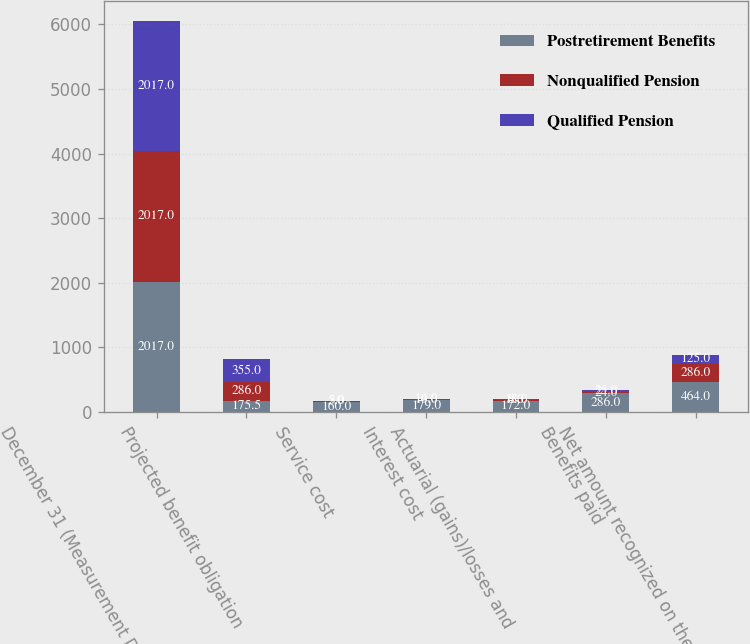Convert chart to OTSL. <chart><loc_0><loc_0><loc_500><loc_500><stacked_bar_chart><ecel><fcel>December 31 (Measurement Date)<fcel>Projected benefit obligation<fcel>Service cost<fcel>Interest cost<fcel>Actuarial (gains)/losses and<fcel>Benefits paid<fcel>Net amount recognized on the<nl><fcel>Postretirement Benefits<fcel>2017<fcel>175.5<fcel>160<fcel>179<fcel>172<fcel>286<fcel>464<nl><fcel>Nonqualified Pension<fcel>2017<fcel>286<fcel>3<fcel>10<fcel>8<fcel>24<fcel>286<nl><fcel>Qualified Pension<fcel>2017<fcel>355<fcel>5<fcel>14<fcel>18<fcel>25<fcel>125<nl></chart> 